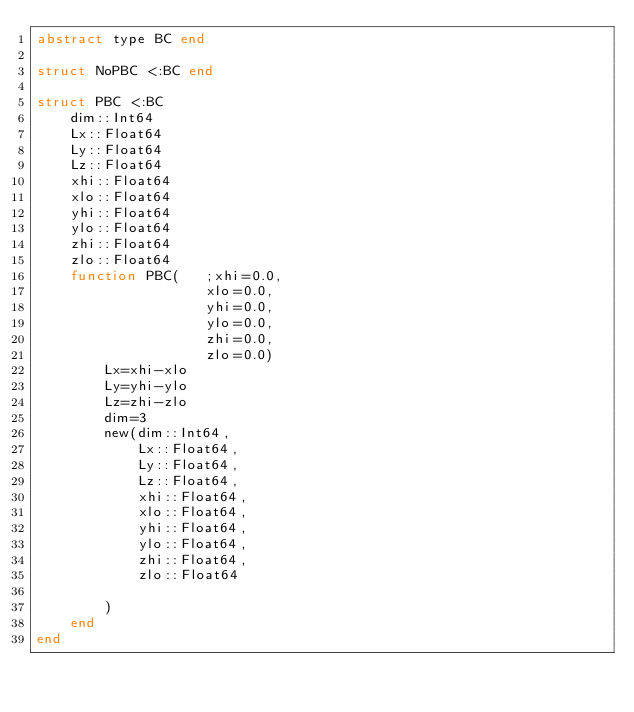Convert code to text. <code><loc_0><loc_0><loc_500><loc_500><_Julia_>abstract type BC end

struct NoPBC <:BC end

struct PBC <:BC
    dim::Int64
    Lx::Float64
    Ly::Float64
    Lz::Float64
    xhi::Float64
    xlo::Float64
    yhi::Float64
    ylo::Float64
    zhi::Float64
    zlo::Float64
    function PBC(   ;xhi=0.0,
                    xlo=0.0,
                    yhi=0.0,
                    ylo=0.0,
                    zhi=0.0,
                    zlo=0.0)
        Lx=xhi-xlo
        Ly=yhi-ylo
        Lz=zhi-zlo
        dim=3
        new(dim::Int64,
            Lx::Float64,
            Ly::Float64,
            Lz::Float64,
            xhi::Float64,
            xlo::Float64,
            yhi::Float64,
            ylo::Float64,
            zhi::Float64,
            zlo::Float64

        )
    end
end
</code> 